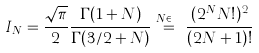<formula> <loc_0><loc_0><loc_500><loc_500>I _ { N } = \frac { \sqrt { \pi } } 2 \frac { \Gamma ( 1 + N ) } { \Gamma ( 3 / 2 + N ) } \overset { N \in \mathbb { N } } { = } \frac { ( 2 ^ { N } N ! ) ^ { 2 } } { ( 2 N + 1 ) ! } \\</formula> 